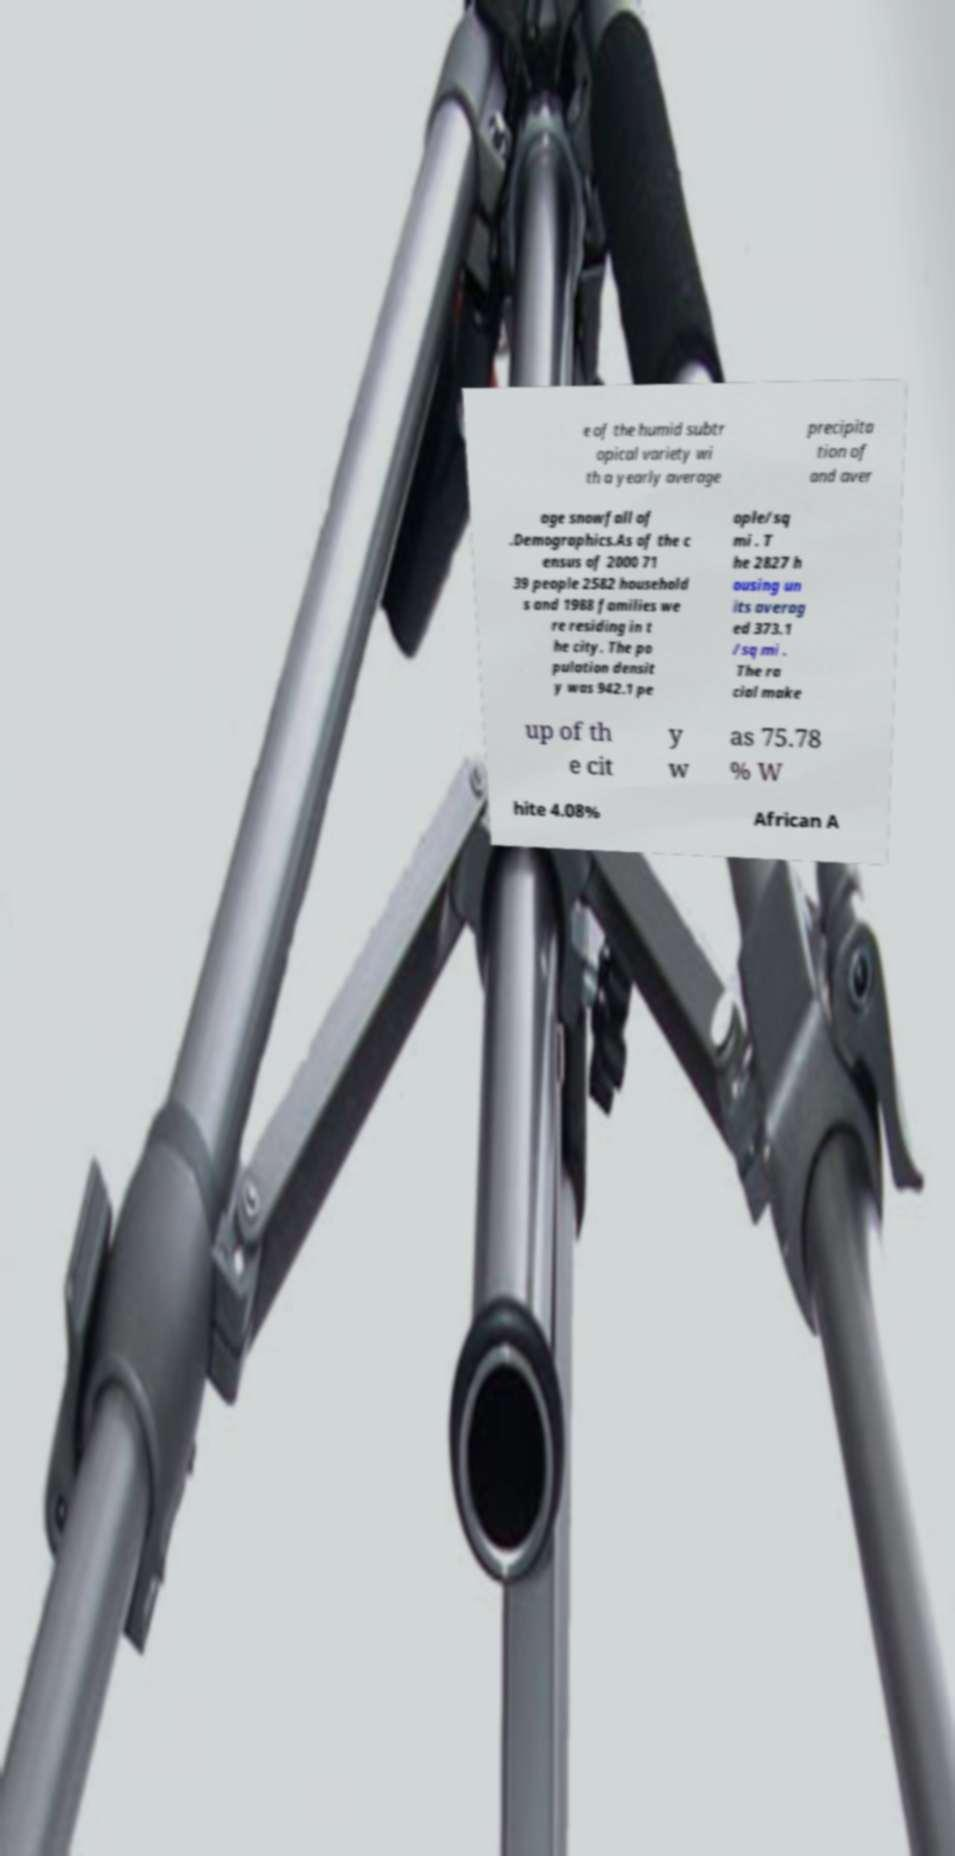Could you assist in decoding the text presented in this image and type it out clearly? e of the humid subtr opical variety wi th a yearly average precipita tion of and aver age snowfall of .Demographics.As of the c ensus of 2000 71 39 people 2582 household s and 1988 families we re residing in t he city. The po pulation densit y was 942.1 pe ople/sq mi . T he 2827 h ousing un its averag ed 373.1 /sq mi . The ra cial make up of th e cit y w as 75.78 % W hite 4.08% African A 